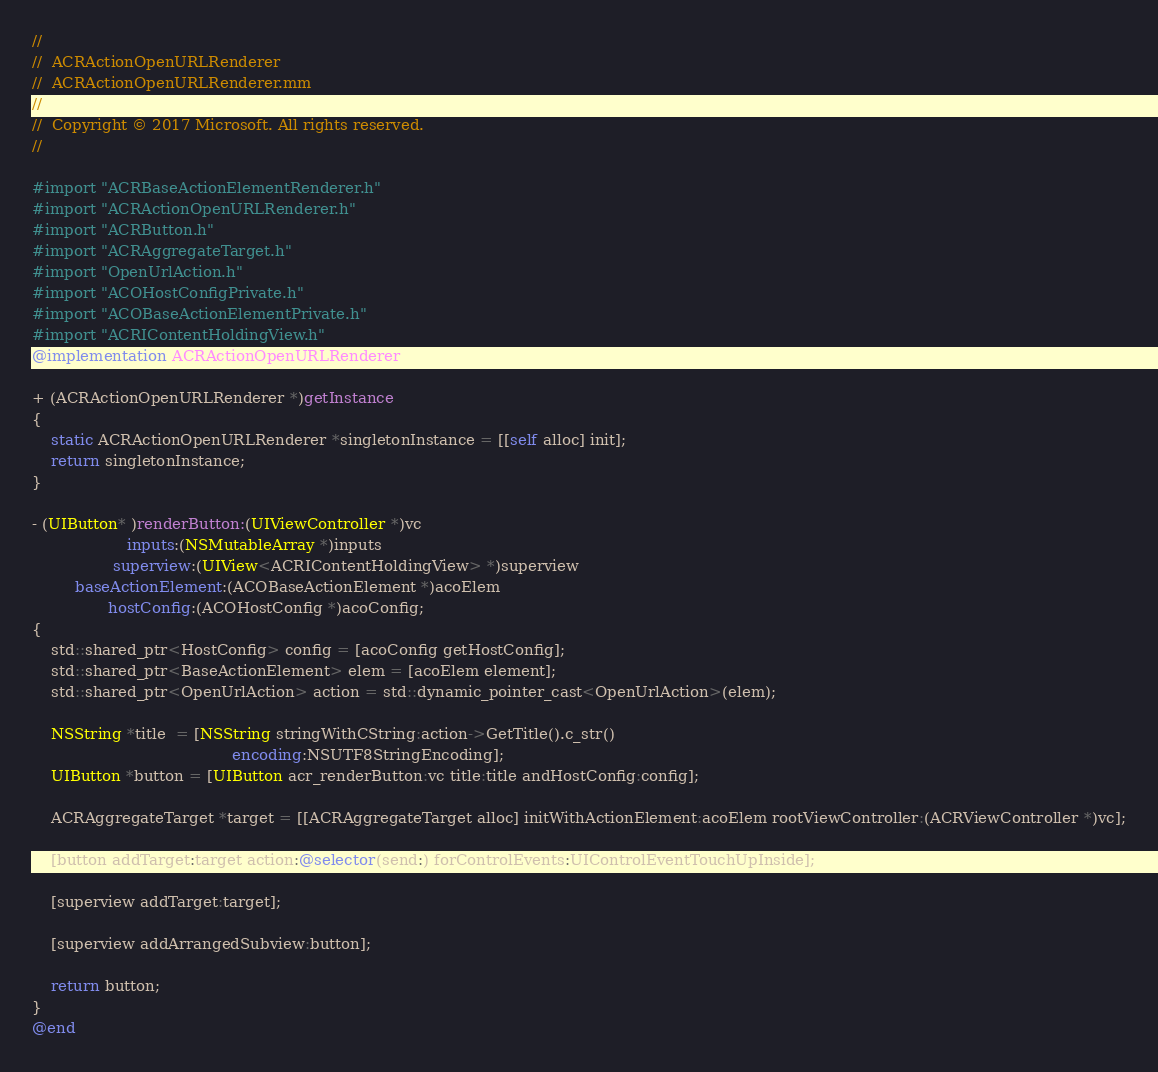Convert code to text. <code><loc_0><loc_0><loc_500><loc_500><_ObjectiveC_>//
//  ACRActionOpenURLRenderer
//  ACRActionOpenURLRenderer.mm
//
//  Copyright © 2017 Microsoft. All rights reserved.
//

#import "ACRBaseActionElementRenderer.h"
#import "ACRActionOpenURLRenderer.h"
#import "ACRButton.h"
#import "ACRAggregateTarget.h"
#import "OpenUrlAction.h"
#import "ACOHostConfigPrivate.h"
#import "ACOBaseActionElementPrivate.h"
#import "ACRIContentHoldingView.h"
@implementation ACRActionOpenURLRenderer

+ (ACRActionOpenURLRenderer *)getInstance
{
    static ACRActionOpenURLRenderer *singletonInstance = [[self alloc] init];
    return singletonInstance;
}

- (UIButton* )renderButton:(UIViewController *)vc
                    inputs:(NSMutableArray *)inputs
                 superview:(UIView<ACRIContentHoldingView> *)superview
         baseActionElement:(ACOBaseActionElement *)acoElem
                hostConfig:(ACOHostConfig *)acoConfig;
{
    std::shared_ptr<HostConfig> config = [acoConfig getHostConfig];
    std::shared_ptr<BaseActionElement> elem = [acoElem element];
    std::shared_ptr<OpenUrlAction> action = std::dynamic_pointer_cast<OpenUrlAction>(elem);

    NSString *title  = [NSString stringWithCString:action->GetTitle().c_str()
                                          encoding:NSUTF8StringEncoding];
    UIButton *button = [UIButton acr_renderButton:vc title:title andHostConfig:config];

    ACRAggregateTarget *target = [[ACRAggregateTarget alloc] initWithActionElement:acoElem rootViewController:(ACRViewController *)vc];

    [button addTarget:target action:@selector(send:) forControlEvents:UIControlEventTouchUpInside];

    [superview addTarget:target];

    [superview addArrangedSubview:button];

    return button;
}
@end
</code> 